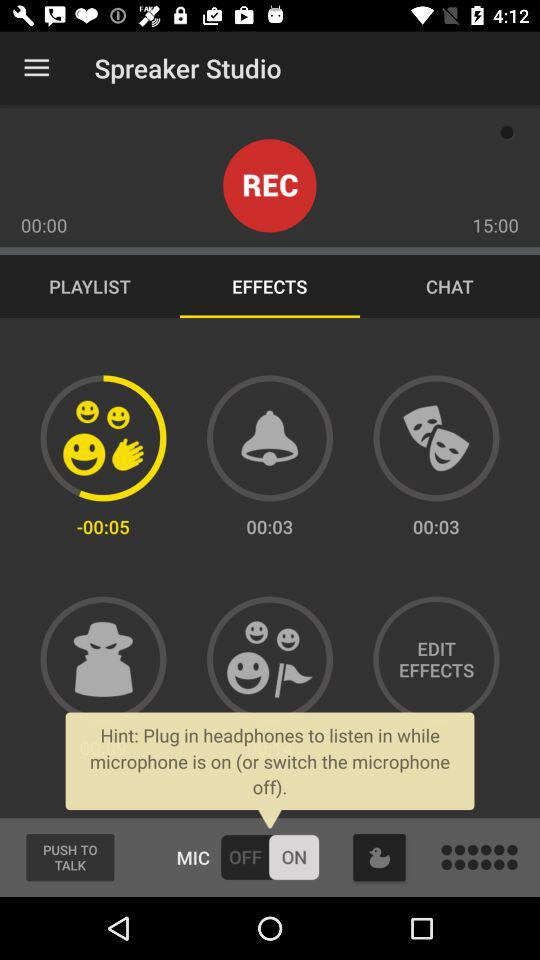What is the application name? The application name is "Spreaker Studio". 